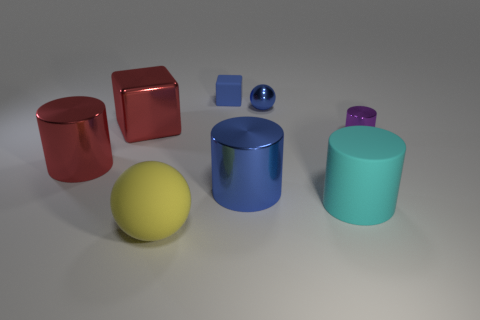How many objects are green spheres or large things that are right of the shiny cube?
Offer a terse response. 3. Are there more tiny blue matte blocks that are behind the big yellow matte thing than blue rubber blocks to the right of the tiny purple cylinder?
Your response must be concise. Yes. The metal thing that is right of the cyan thing that is to the right of the block left of the large yellow rubber ball is what shape?
Offer a terse response. Cylinder. What is the shape of the small blue object in front of the block on the right side of the large yellow rubber ball?
Keep it short and to the point. Sphere. Are there any green spheres made of the same material as the big cyan cylinder?
Provide a short and direct response. No. There is a shiny cylinder that is the same color as the shiny cube; what size is it?
Your answer should be very brief. Large. How many gray things are big rubber spheres or small spheres?
Ensure brevity in your answer.  0. Are there any tiny matte cubes of the same color as the small shiny sphere?
Ensure brevity in your answer.  Yes. There is a cylinder that is the same material as the big yellow thing; what size is it?
Offer a terse response. Large. What number of balls are large cyan things or blue rubber objects?
Ensure brevity in your answer.  0. 